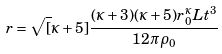<formula> <loc_0><loc_0><loc_500><loc_500>r = \sqrt { [ } \kappa + 5 ] { \frac { ( \kappa + 3 ) ( \kappa + 5 ) r _ { 0 } ^ { \kappa } L t ^ { 3 } } { 1 2 \pi \rho _ { 0 } } }</formula> 